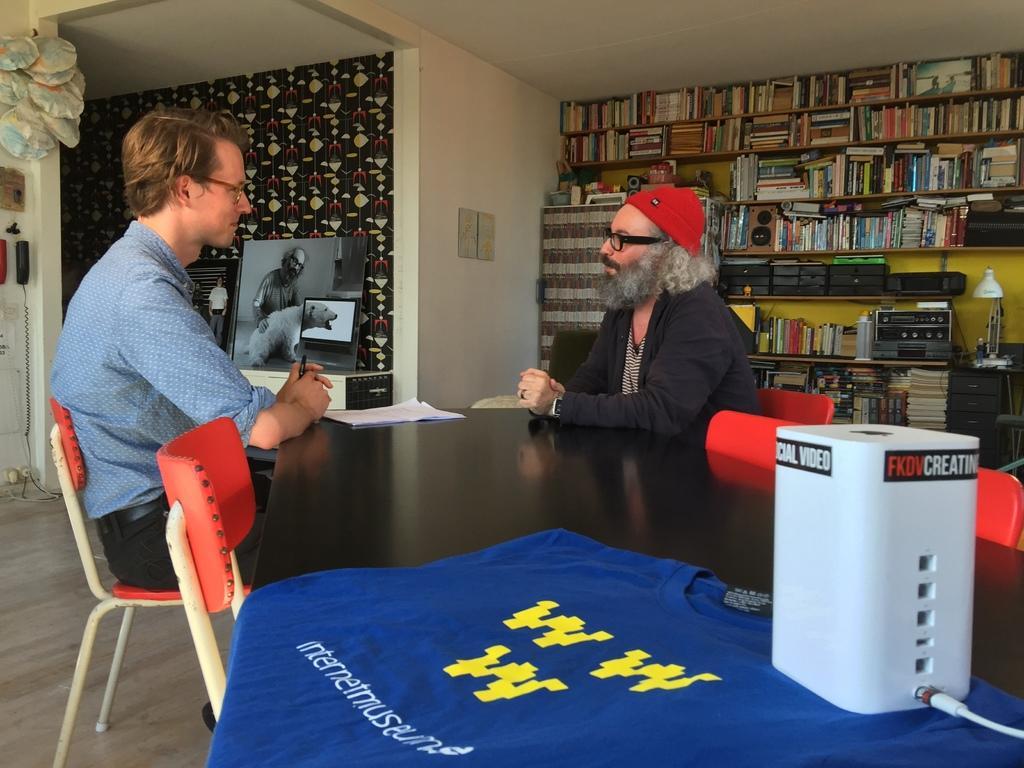Could you give a brief overview of what you see in this image? There are 2 people here sitting on the chair at the table. On the table there are papers and a t-Shirt. In the background we can see number of books in bookshelf,table,cupboard,lamp,frames on the wall. 